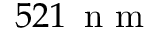Convert formula to latex. <formula><loc_0><loc_0><loc_500><loc_500>5 2 1 \, n m</formula> 